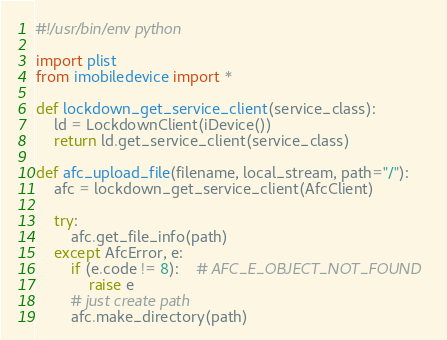<code> <loc_0><loc_0><loc_500><loc_500><_Python_>#!/usr/bin/env python

import plist
from imobiledevice import *

def lockdown_get_service_client(service_class):
	ld = LockdownClient(iDevice())
	return ld.get_service_client(service_class)

def afc_upload_file(filename, local_stream, path="/"):
	afc = lockdown_get_service_client(AfcClient)

	try:
		afc.get_file_info(path)
	except AfcError, e:
		if (e.code != 8):	# AFC_E_OBJECT_NOT_FOUND
			raise e
		# just create path
		afc.make_directory(path)
</code> 